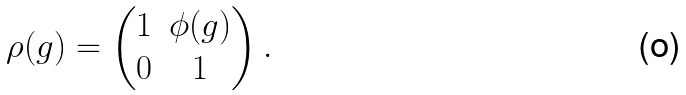<formula> <loc_0><loc_0><loc_500><loc_500>\rho ( g ) = \begin{pmatrix} 1 & \phi ( g ) \\ 0 & 1 \end{pmatrix} .</formula> 